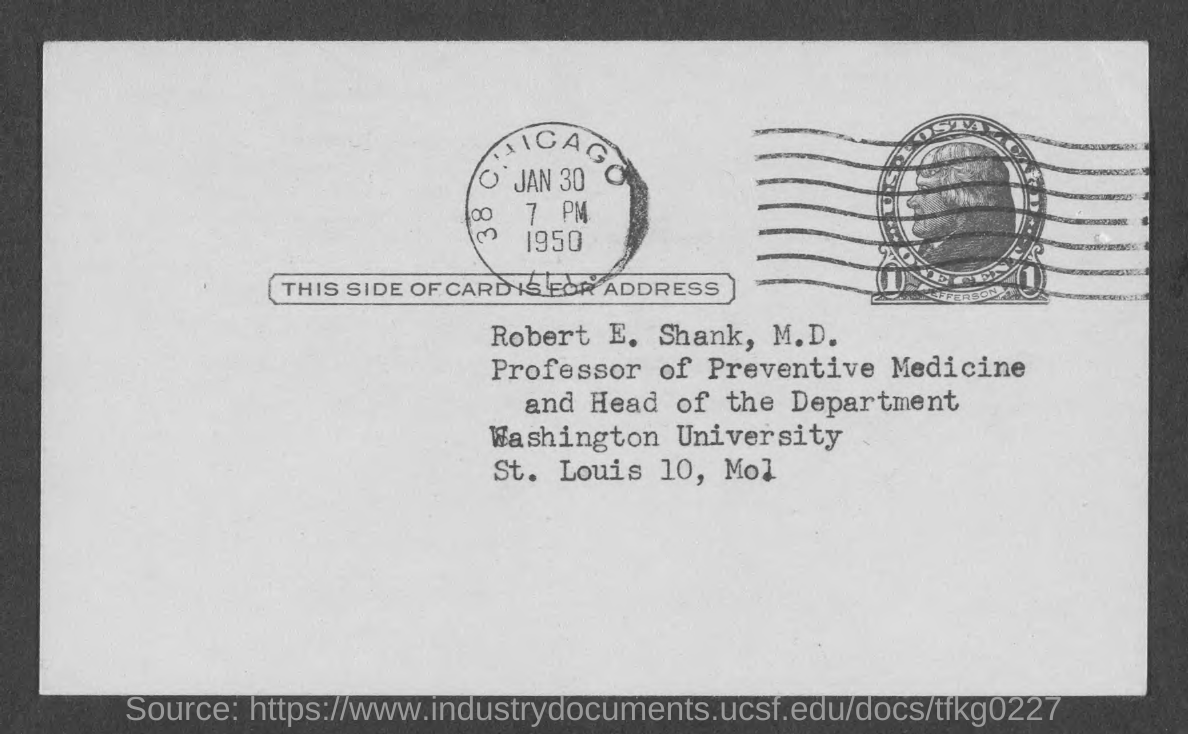Point out several critical features in this image. It is currently 7:00 PM. 